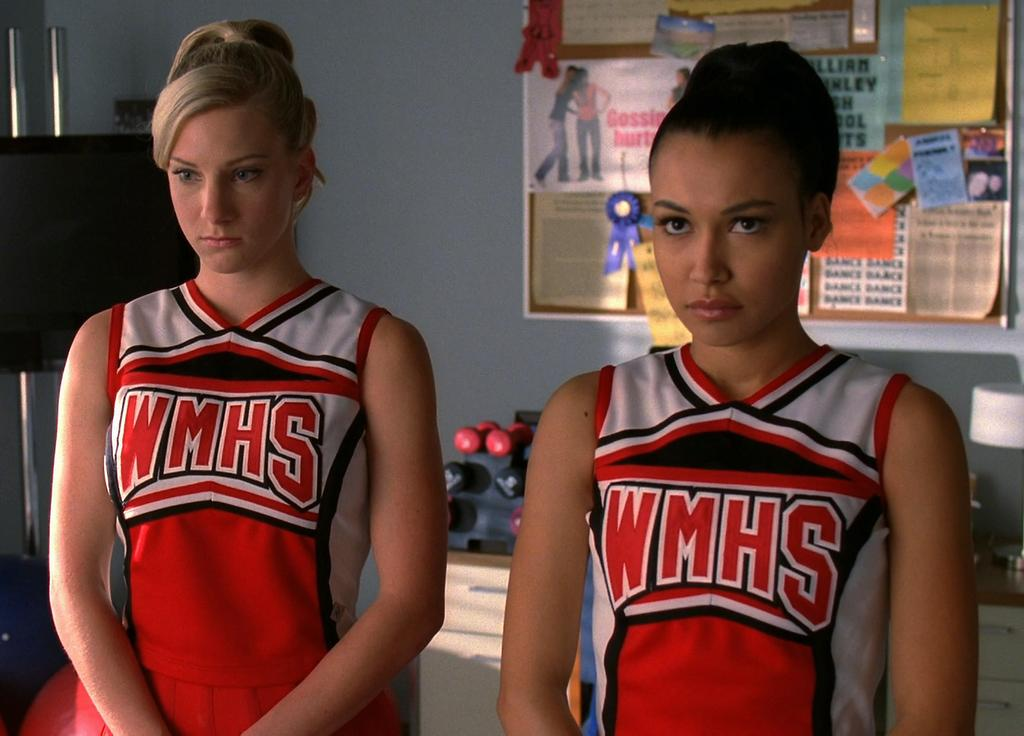<image>
Render a clear and concise summary of the photo. Two young women stand in front of a noticeboard wearing WMHS tops. 